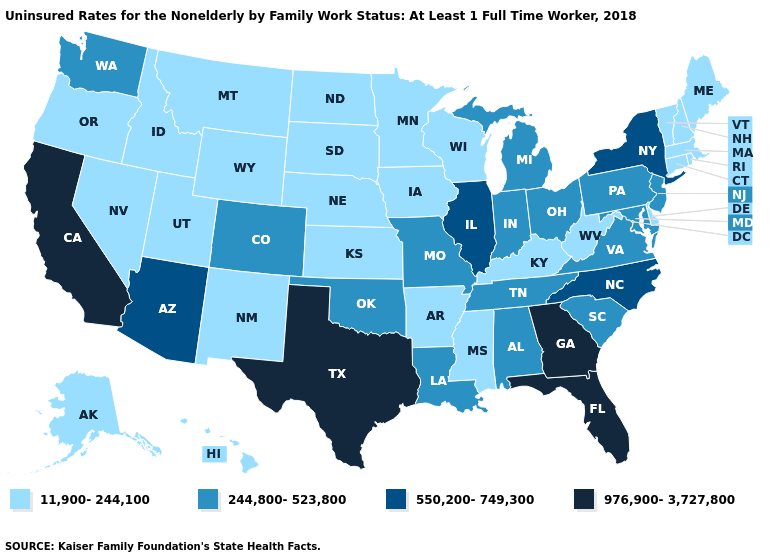What is the value of Wisconsin?
Quick response, please. 11,900-244,100. Name the states that have a value in the range 976,900-3,727,800?
Answer briefly. California, Florida, Georgia, Texas. What is the highest value in the USA?
Write a very short answer. 976,900-3,727,800. Name the states that have a value in the range 11,900-244,100?
Quick response, please. Alaska, Arkansas, Connecticut, Delaware, Hawaii, Idaho, Iowa, Kansas, Kentucky, Maine, Massachusetts, Minnesota, Mississippi, Montana, Nebraska, Nevada, New Hampshire, New Mexico, North Dakota, Oregon, Rhode Island, South Dakota, Utah, Vermont, West Virginia, Wisconsin, Wyoming. What is the highest value in the USA?
Write a very short answer. 976,900-3,727,800. Does Connecticut have the lowest value in the Northeast?
Short answer required. Yes. Which states have the highest value in the USA?
Answer briefly. California, Florida, Georgia, Texas. What is the highest value in the West ?
Answer briefly. 976,900-3,727,800. What is the value of Mississippi?
Short answer required. 11,900-244,100. What is the value of Maryland?
Be succinct. 244,800-523,800. Which states hav the highest value in the MidWest?
Write a very short answer. Illinois. What is the value of South Carolina?
Write a very short answer. 244,800-523,800. Which states hav the highest value in the West?
Quick response, please. California. Name the states that have a value in the range 244,800-523,800?
Quick response, please. Alabama, Colorado, Indiana, Louisiana, Maryland, Michigan, Missouri, New Jersey, Ohio, Oklahoma, Pennsylvania, South Carolina, Tennessee, Virginia, Washington. 